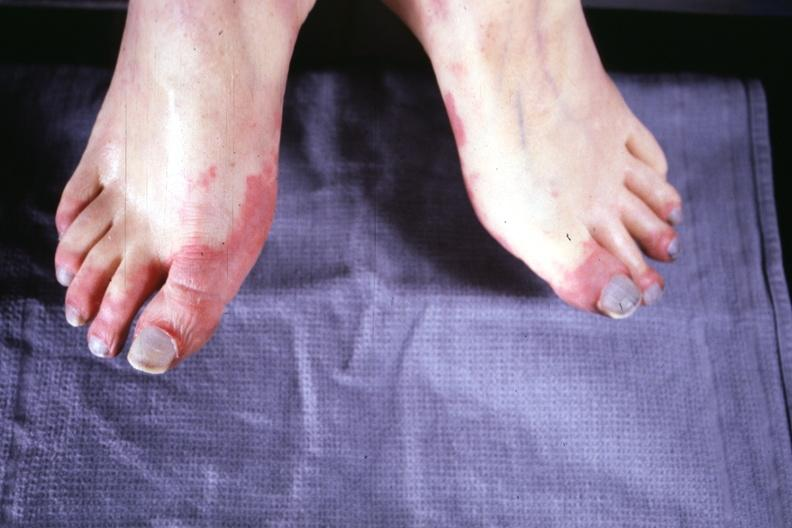does this image show early lesion with erythematous appearance?
Answer the question using a single word or phrase. Yes 